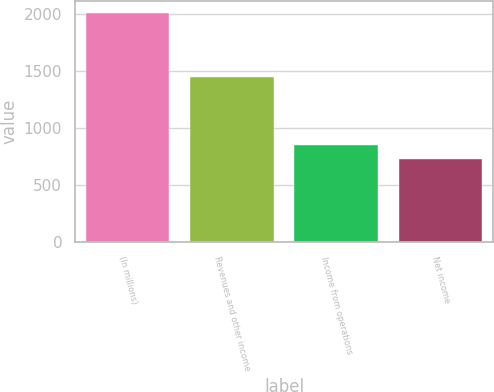<chart> <loc_0><loc_0><loc_500><loc_500><bar_chart><fcel>(In millions)<fcel>Revenues and other income<fcel>Income from operations<fcel>Net income<nl><fcel>2013<fcel>1444<fcel>855.6<fcel>727<nl></chart> 